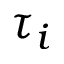<formula> <loc_0><loc_0><loc_500><loc_500>\tau _ { i }</formula> 